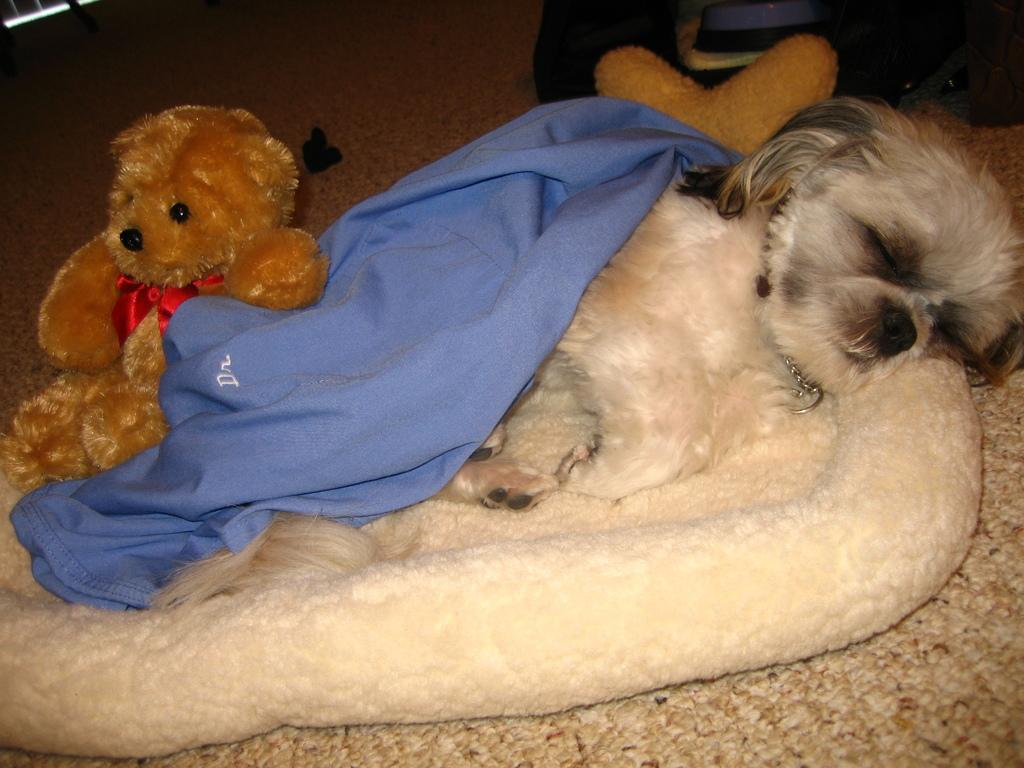What is the main subject in the center of the image? There is a dog in the center of the image. What is the dog doing in the image? The dog is sleeping. What can be seen on the left side of the image? There is a toy on the left side of the image. What is located at the bottom of the image? There is furniture at the bottom of the image. Can you provide an example of a girl in the image? There is no girl present in the image; it features a dog sleeping and a toy on the left side. 